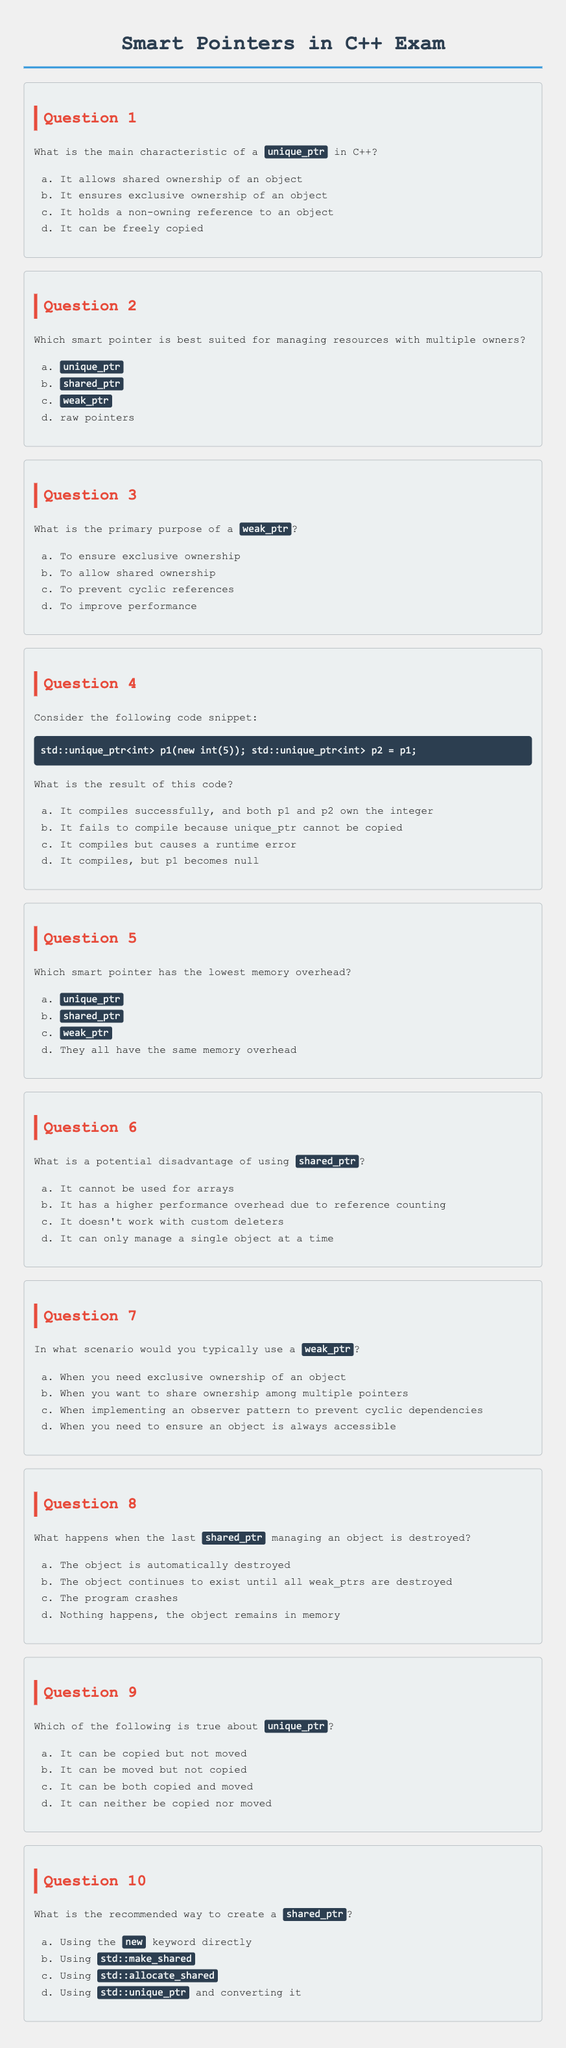What is the title of the exam? The title of the exam is provided in the document as "Smart Pointers in C++ Exam".
Answer: Smart Pointers in C++ Exam How many questions are contained in the document? The document contains a total of 10 questions, as indicated by the numbering from Question 1 to Question 10.
Answer: 10 What is the correct answer to Question 1? Question 1 asks about the main characteristic of a unique_ptr, and the correct answer is listed as option (b) "It ensures exclusive ownership of an object".
Answer: It ensures exclusive ownership of an object Which smart pointer is best suited for managing resources with multiple owners? The answer to this is presented in Question 2, which indicates that shared_ptr is best suited for this purpose.
Answer: shared_ptr What happens when the last shared_ptr managing an object is destroyed? The answer to this is provided in Question 8, indicating that the object is automatically destroyed.
Answer: The object is automatically destroyed What does Question 5 ask about? Question 5 inquires about which smart pointer has the lowest memory overhead, testing knowledge of memory considerations for different smart pointers.
Answer: Which smart pointer has the lowest memory overhead? What is stated as a potential disadvantage of using shared_ptr in Question 6? Question 6 lists that having a higher performance overhead due to reference counting is a potential disadvantage of using shared_ptr.
Answer: It has a higher performance overhead due to reference counting What method is recommended for creating a shared_ptr? The answer is provided in Question 10, advising the use of std::make_shared.
Answer: Using std::make_shared 